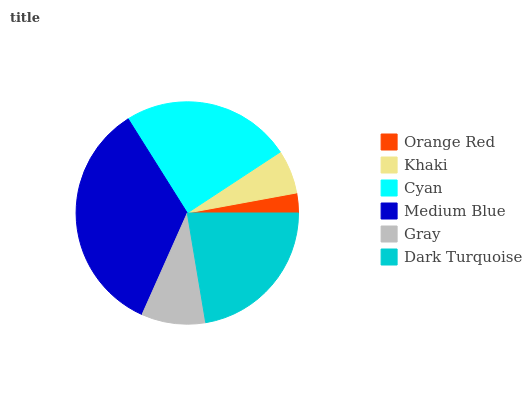Is Orange Red the minimum?
Answer yes or no. Yes. Is Medium Blue the maximum?
Answer yes or no. Yes. Is Khaki the minimum?
Answer yes or no. No. Is Khaki the maximum?
Answer yes or no. No. Is Khaki greater than Orange Red?
Answer yes or no. Yes. Is Orange Red less than Khaki?
Answer yes or no. Yes. Is Orange Red greater than Khaki?
Answer yes or no. No. Is Khaki less than Orange Red?
Answer yes or no. No. Is Dark Turquoise the high median?
Answer yes or no. Yes. Is Gray the low median?
Answer yes or no. Yes. Is Khaki the high median?
Answer yes or no. No. Is Cyan the low median?
Answer yes or no. No. 